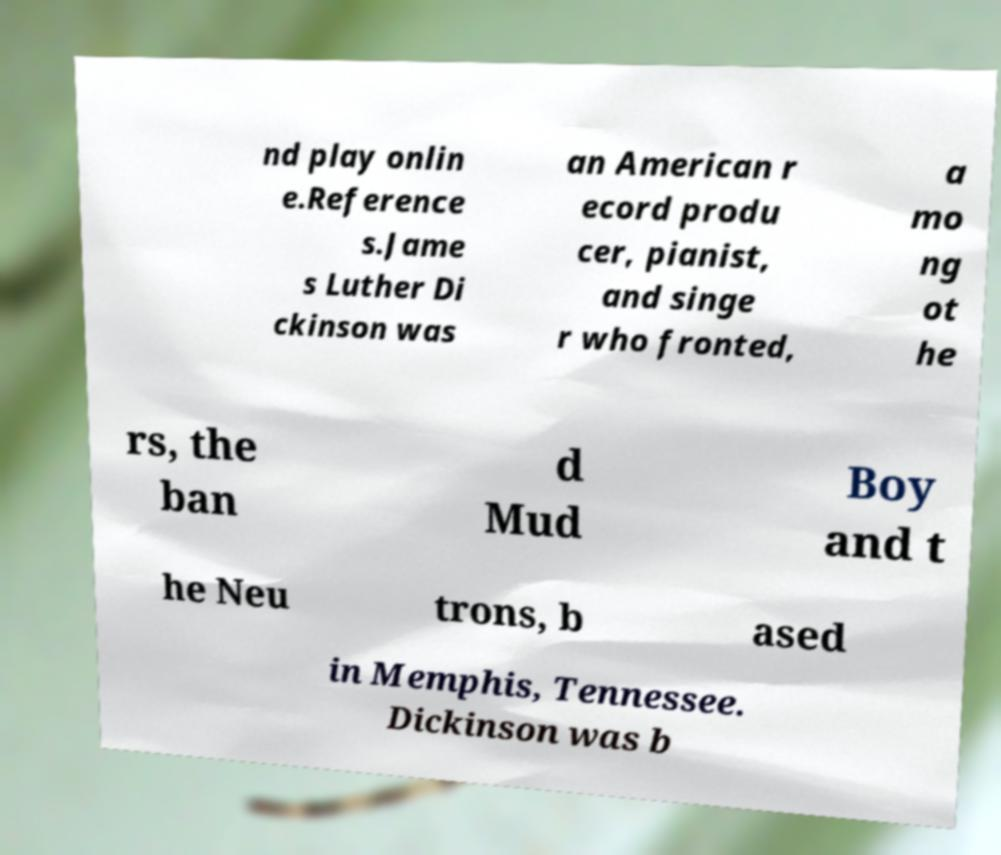Please identify and transcribe the text found in this image. nd play onlin e.Reference s.Jame s Luther Di ckinson was an American r ecord produ cer, pianist, and singe r who fronted, a mo ng ot he rs, the ban d Mud Boy and t he Neu trons, b ased in Memphis, Tennessee. Dickinson was b 